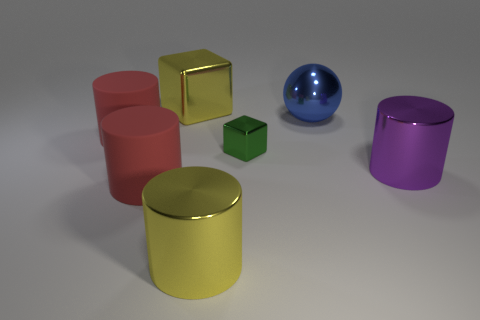Add 1 tiny blue spheres. How many objects exist? 8 Subtract all balls. How many objects are left? 6 Subtract 0 brown blocks. How many objects are left? 7 Subtract all blue cubes. Subtract all small green cubes. How many objects are left? 6 Add 2 purple metal objects. How many purple metal objects are left? 3 Add 4 purple metal objects. How many purple metal objects exist? 5 